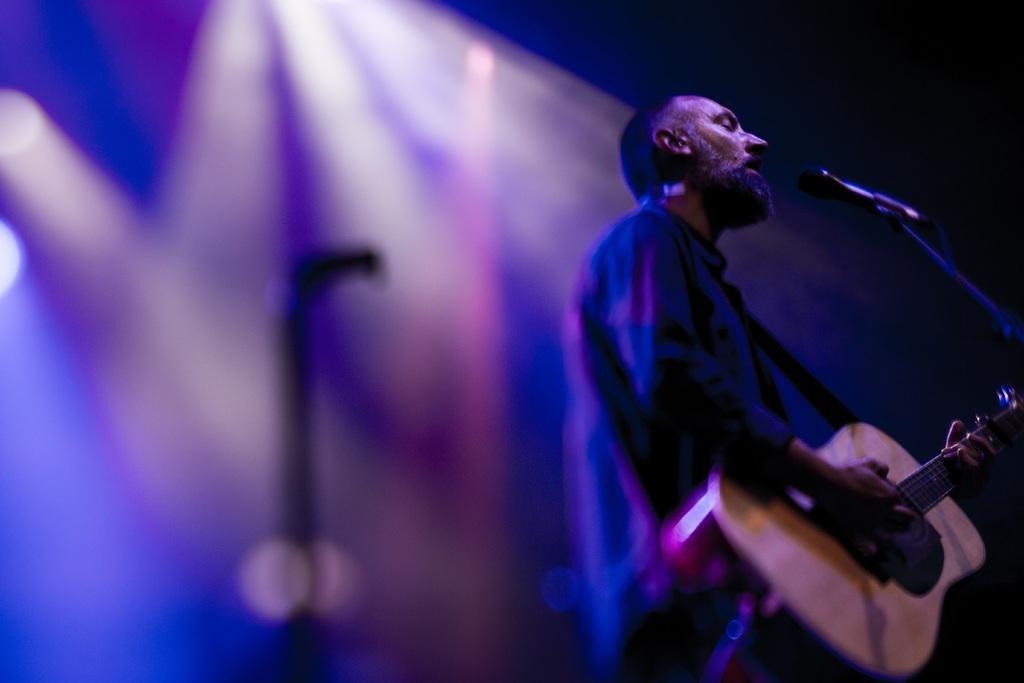Can you describe this image briefly? In this image a man is standing and holding a guitar in his hand. In front of him there is a mic. 